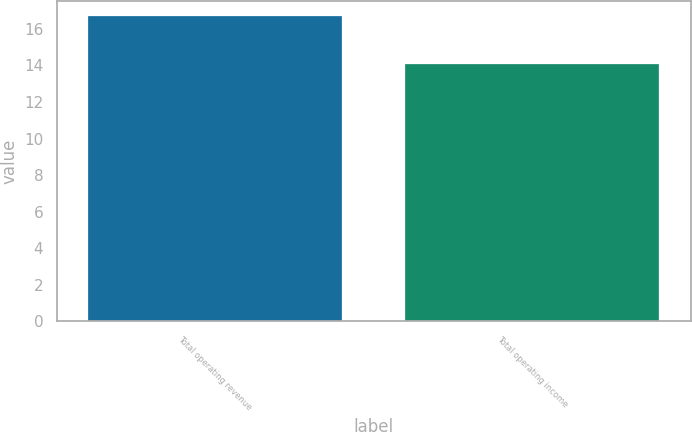<chart> <loc_0><loc_0><loc_500><loc_500><bar_chart><fcel>Total operating revenue<fcel>Total operating income<nl><fcel>16.7<fcel>14.1<nl></chart> 